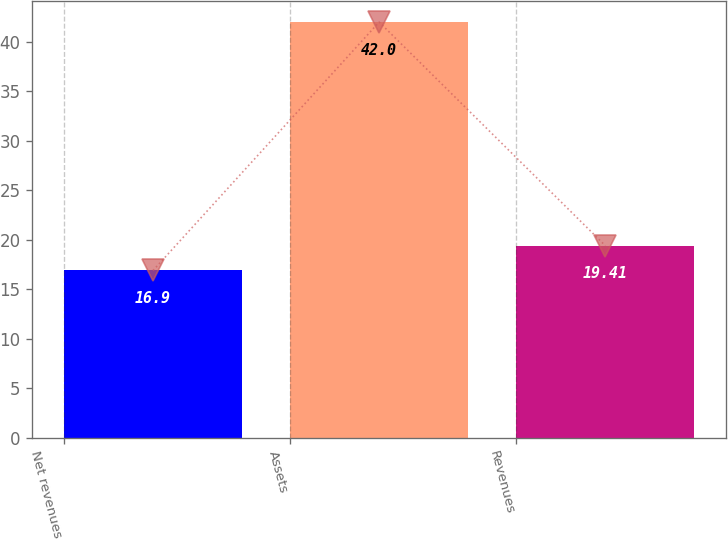Convert chart. <chart><loc_0><loc_0><loc_500><loc_500><bar_chart><fcel>Net revenues<fcel>Assets<fcel>Revenues<nl><fcel>16.9<fcel>42<fcel>19.41<nl></chart> 